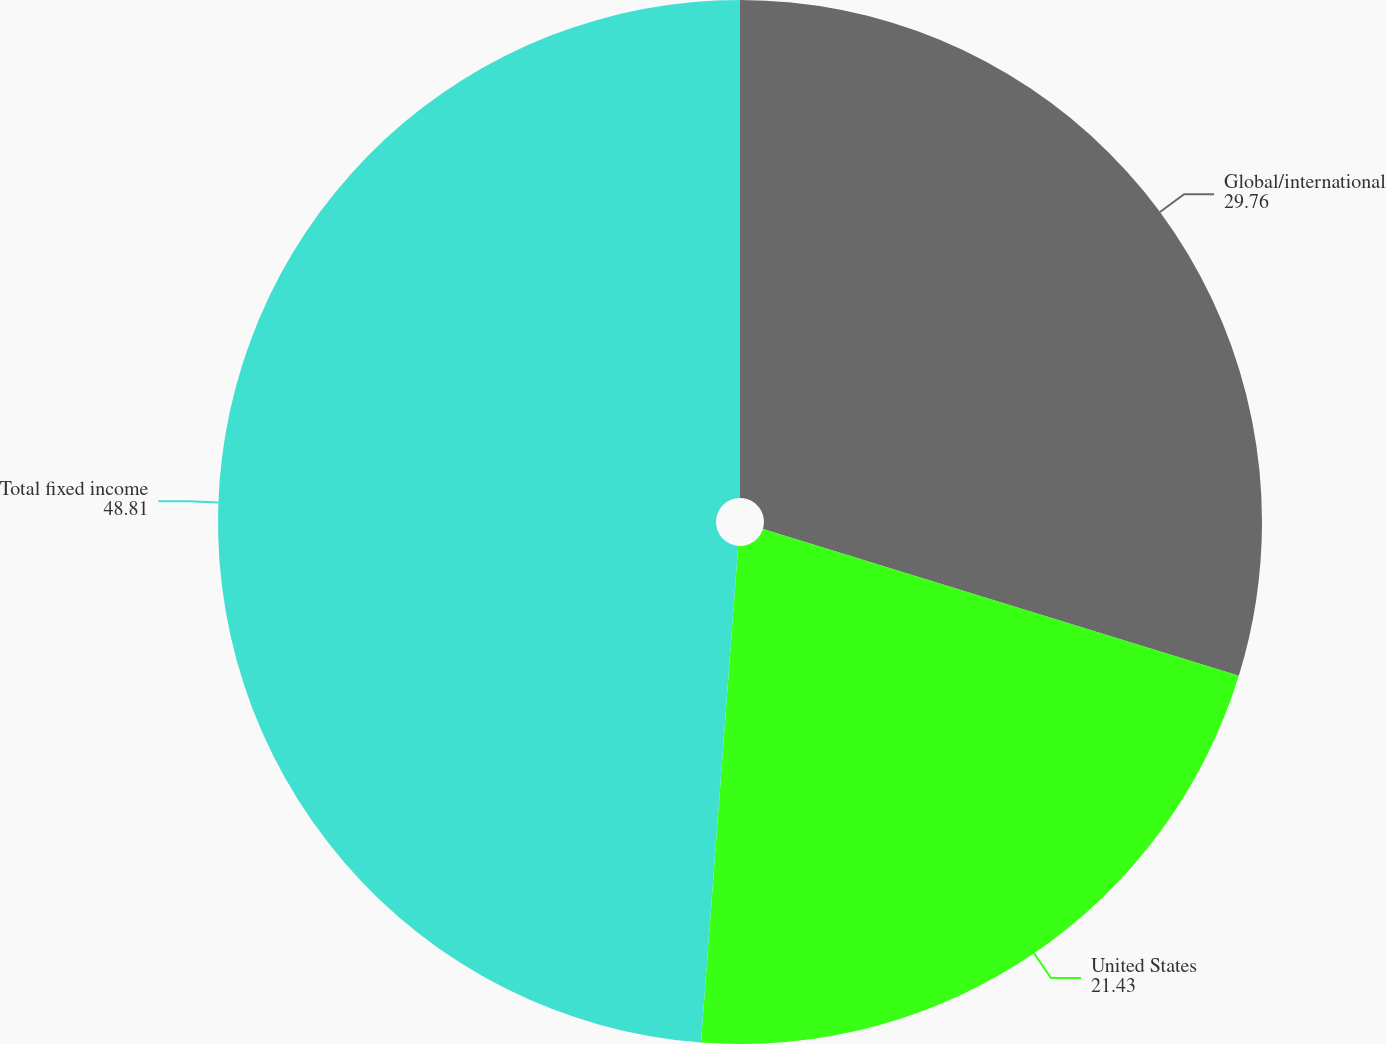<chart> <loc_0><loc_0><loc_500><loc_500><pie_chart><fcel>Global/international<fcel>United States<fcel>Total fixed income<nl><fcel>29.76%<fcel>21.43%<fcel>48.81%<nl></chart> 